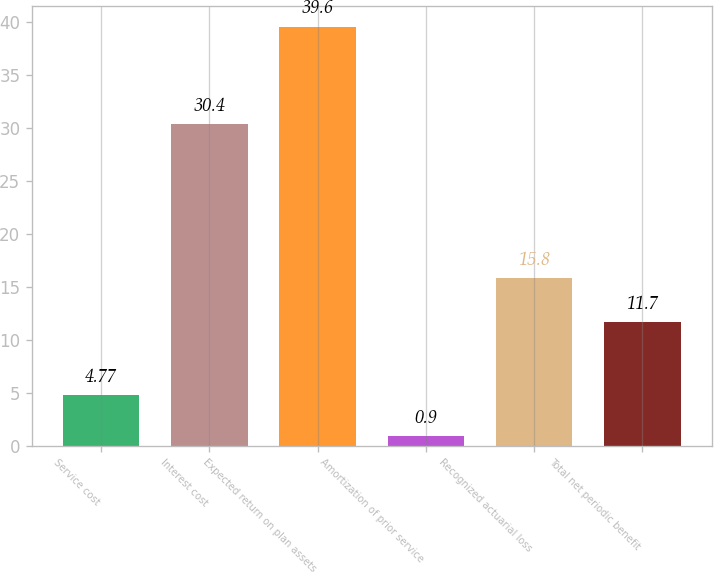Convert chart to OTSL. <chart><loc_0><loc_0><loc_500><loc_500><bar_chart><fcel>Service cost<fcel>Interest cost<fcel>Expected return on plan assets<fcel>Amortization of prior service<fcel>Recognized actuarial loss<fcel>Total net periodic benefit<nl><fcel>4.77<fcel>30.4<fcel>39.6<fcel>0.9<fcel>15.8<fcel>11.7<nl></chart> 